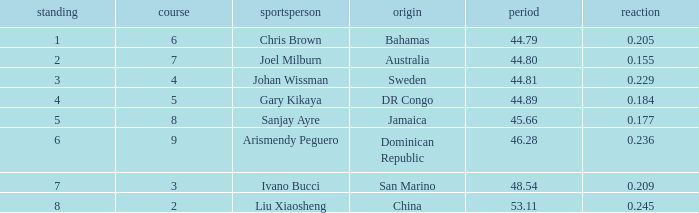What is the total average for Rank entries where the Lane listed is smaller than 4 and the Nationality listed is San Marino? 7.0. Write the full table. {'header': ['standing', 'course', 'sportsperson', 'origin', 'period', 'reaction'], 'rows': [['1', '6', 'Chris Brown', 'Bahamas', '44.79', '0.205'], ['2', '7', 'Joel Milburn', 'Australia', '44.80', '0.155'], ['3', '4', 'Johan Wissman', 'Sweden', '44.81', '0.229'], ['4', '5', 'Gary Kikaya', 'DR Congo', '44.89', '0.184'], ['5', '8', 'Sanjay Ayre', 'Jamaica', '45.66', '0.177'], ['6', '9', 'Arismendy Peguero', 'Dominican Republic', '46.28', '0.236'], ['7', '3', 'Ivano Bucci', 'San Marino', '48.54', '0.209'], ['8', '2', 'Liu Xiaosheng', 'China', '53.11', '0.245']]} 